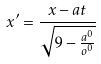<formula> <loc_0><loc_0><loc_500><loc_500>x ^ { \prime } = \frac { x - a t } { \sqrt { 9 - \frac { a ^ { 0 } } { o ^ { 0 } } } }</formula> 